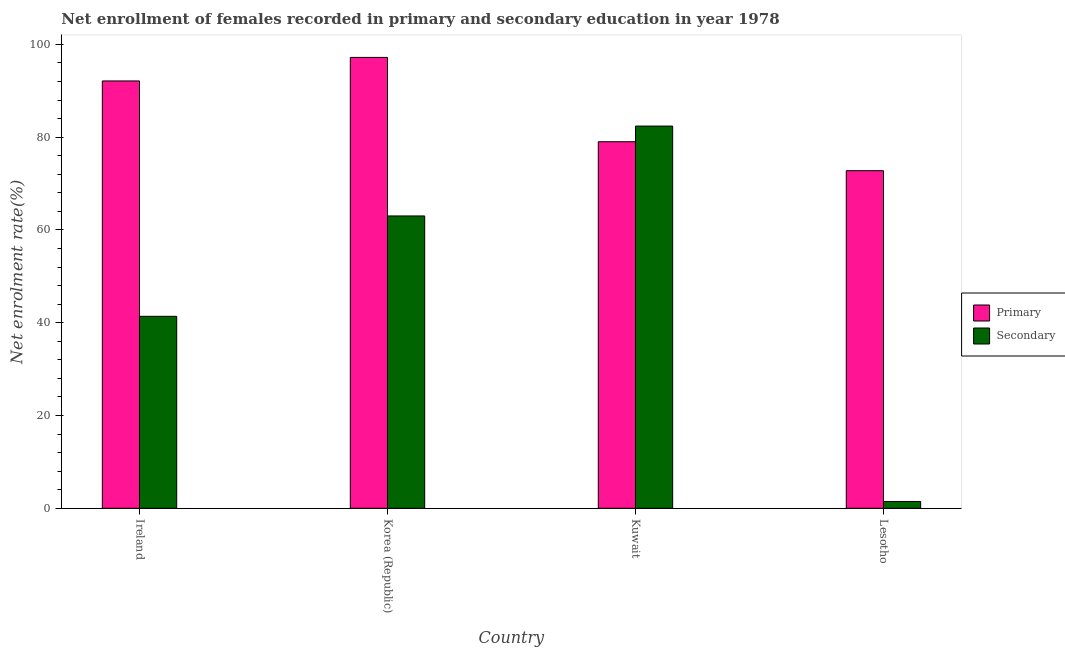How many groups of bars are there?
Offer a terse response. 4. How many bars are there on the 4th tick from the right?
Ensure brevity in your answer.  2. What is the label of the 4th group of bars from the left?
Ensure brevity in your answer.  Lesotho. In how many cases, is the number of bars for a given country not equal to the number of legend labels?
Keep it short and to the point. 0. What is the enrollment rate in primary education in Korea (Republic)?
Your answer should be compact. 97.18. Across all countries, what is the maximum enrollment rate in primary education?
Your answer should be compact. 97.18. Across all countries, what is the minimum enrollment rate in primary education?
Ensure brevity in your answer.  72.76. In which country was the enrollment rate in secondary education minimum?
Offer a very short reply. Lesotho. What is the total enrollment rate in primary education in the graph?
Ensure brevity in your answer.  341.07. What is the difference between the enrollment rate in primary education in Korea (Republic) and that in Kuwait?
Ensure brevity in your answer.  18.17. What is the difference between the enrollment rate in secondary education in Korea (Republic) and the enrollment rate in primary education in Ireland?
Offer a very short reply. -29.1. What is the average enrollment rate in secondary education per country?
Offer a terse response. 47.06. What is the difference between the enrollment rate in secondary education and enrollment rate in primary education in Lesotho?
Give a very brief answer. -71.3. In how many countries, is the enrollment rate in primary education greater than 68 %?
Your response must be concise. 4. What is the ratio of the enrollment rate in primary education in Korea (Republic) to that in Kuwait?
Your answer should be very brief. 1.23. Is the enrollment rate in primary education in Ireland less than that in Korea (Republic)?
Your answer should be compact. Yes. What is the difference between the highest and the second highest enrollment rate in secondary education?
Ensure brevity in your answer.  19.37. What is the difference between the highest and the lowest enrollment rate in primary education?
Keep it short and to the point. 24.42. In how many countries, is the enrollment rate in primary education greater than the average enrollment rate in primary education taken over all countries?
Offer a terse response. 2. What does the 1st bar from the left in Lesotho represents?
Offer a very short reply. Primary. What does the 1st bar from the right in Lesotho represents?
Your answer should be very brief. Secondary. How many countries are there in the graph?
Give a very brief answer. 4. What is the difference between two consecutive major ticks on the Y-axis?
Ensure brevity in your answer.  20. Does the graph contain grids?
Your response must be concise. No. Where does the legend appear in the graph?
Your response must be concise. Center right. How many legend labels are there?
Provide a short and direct response. 2. How are the legend labels stacked?
Keep it short and to the point. Vertical. What is the title of the graph?
Give a very brief answer. Net enrollment of females recorded in primary and secondary education in year 1978. Does "Central government" appear as one of the legend labels in the graph?
Your answer should be very brief. No. What is the label or title of the Y-axis?
Ensure brevity in your answer.  Net enrolment rate(%). What is the Net enrolment rate(%) in Primary in Ireland?
Keep it short and to the point. 92.11. What is the Net enrolment rate(%) in Secondary in Ireland?
Offer a very short reply. 41.38. What is the Net enrolment rate(%) of Primary in Korea (Republic)?
Provide a short and direct response. 97.18. What is the Net enrolment rate(%) of Secondary in Korea (Republic)?
Your answer should be compact. 63.01. What is the Net enrolment rate(%) of Primary in Kuwait?
Your answer should be compact. 79.01. What is the Net enrolment rate(%) in Secondary in Kuwait?
Keep it short and to the point. 82.38. What is the Net enrolment rate(%) in Primary in Lesotho?
Offer a very short reply. 72.76. What is the Net enrolment rate(%) in Secondary in Lesotho?
Keep it short and to the point. 1.47. Across all countries, what is the maximum Net enrolment rate(%) of Primary?
Your answer should be very brief. 97.18. Across all countries, what is the maximum Net enrolment rate(%) of Secondary?
Your answer should be compact. 82.38. Across all countries, what is the minimum Net enrolment rate(%) in Primary?
Provide a succinct answer. 72.76. Across all countries, what is the minimum Net enrolment rate(%) in Secondary?
Provide a succinct answer. 1.47. What is the total Net enrolment rate(%) in Primary in the graph?
Provide a short and direct response. 341.07. What is the total Net enrolment rate(%) of Secondary in the graph?
Ensure brevity in your answer.  188.24. What is the difference between the Net enrolment rate(%) in Primary in Ireland and that in Korea (Republic)?
Provide a succinct answer. -5.07. What is the difference between the Net enrolment rate(%) of Secondary in Ireland and that in Korea (Republic)?
Keep it short and to the point. -21.63. What is the difference between the Net enrolment rate(%) in Primary in Ireland and that in Kuwait?
Give a very brief answer. 13.1. What is the difference between the Net enrolment rate(%) in Secondary in Ireland and that in Kuwait?
Provide a succinct answer. -41.01. What is the difference between the Net enrolment rate(%) of Primary in Ireland and that in Lesotho?
Make the answer very short. 19.34. What is the difference between the Net enrolment rate(%) in Secondary in Ireland and that in Lesotho?
Give a very brief answer. 39.91. What is the difference between the Net enrolment rate(%) in Primary in Korea (Republic) and that in Kuwait?
Provide a short and direct response. 18.17. What is the difference between the Net enrolment rate(%) of Secondary in Korea (Republic) and that in Kuwait?
Offer a terse response. -19.37. What is the difference between the Net enrolment rate(%) of Primary in Korea (Republic) and that in Lesotho?
Provide a short and direct response. 24.42. What is the difference between the Net enrolment rate(%) in Secondary in Korea (Republic) and that in Lesotho?
Provide a short and direct response. 61.54. What is the difference between the Net enrolment rate(%) in Primary in Kuwait and that in Lesotho?
Give a very brief answer. 6.25. What is the difference between the Net enrolment rate(%) in Secondary in Kuwait and that in Lesotho?
Keep it short and to the point. 80.92. What is the difference between the Net enrolment rate(%) of Primary in Ireland and the Net enrolment rate(%) of Secondary in Korea (Republic)?
Your response must be concise. 29.1. What is the difference between the Net enrolment rate(%) in Primary in Ireland and the Net enrolment rate(%) in Secondary in Kuwait?
Your answer should be very brief. 9.73. What is the difference between the Net enrolment rate(%) in Primary in Ireland and the Net enrolment rate(%) in Secondary in Lesotho?
Provide a succinct answer. 90.64. What is the difference between the Net enrolment rate(%) of Primary in Korea (Republic) and the Net enrolment rate(%) of Secondary in Kuwait?
Make the answer very short. 14.8. What is the difference between the Net enrolment rate(%) of Primary in Korea (Republic) and the Net enrolment rate(%) of Secondary in Lesotho?
Your answer should be very brief. 95.72. What is the difference between the Net enrolment rate(%) in Primary in Kuwait and the Net enrolment rate(%) in Secondary in Lesotho?
Make the answer very short. 77.54. What is the average Net enrolment rate(%) of Primary per country?
Offer a very short reply. 85.27. What is the average Net enrolment rate(%) of Secondary per country?
Your answer should be compact. 47.06. What is the difference between the Net enrolment rate(%) in Primary and Net enrolment rate(%) in Secondary in Ireland?
Provide a succinct answer. 50.73. What is the difference between the Net enrolment rate(%) of Primary and Net enrolment rate(%) of Secondary in Korea (Republic)?
Give a very brief answer. 34.17. What is the difference between the Net enrolment rate(%) of Primary and Net enrolment rate(%) of Secondary in Kuwait?
Offer a terse response. -3.37. What is the difference between the Net enrolment rate(%) in Primary and Net enrolment rate(%) in Secondary in Lesotho?
Make the answer very short. 71.3. What is the ratio of the Net enrolment rate(%) in Primary in Ireland to that in Korea (Republic)?
Offer a very short reply. 0.95. What is the ratio of the Net enrolment rate(%) in Secondary in Ireland to that in Korea (Republic)?
Ensure brevity in your answer.  0.66. What is the ratio of the Net enrolment rate(%) of Primary in Ireland to that in Kuwait?
Offer a terse response. 1.17. What is the ratio of the Net enrolment rate(%) of Secondary in Ireland to that in Kuwait?
Keep it short and to the point. 0.5. What is the ratio of the Net enrolment rate(%) in Primary in Ireland to that in Lesotho?
Keep it short and to the point. 1.27. What is the ratio of the Net enrolment rate(%) of Secondary in Ireland to that in Lesotho?
Your answer should be very brief. 28.23. What is the ratio of the Net enrolment rate(%) of Primary in Korea (Republic) to that in Kuwait?
Offer a very short reply. 1.23. What is the ratio of the Net enrolment rate(%) of Secondary in Korea (Republic) to that in Kuwait?
Offer a very short reply. 0.76. What is the ratio of the Net enrolment rate(%) in Primary in Korea (Republic) to that in Lesotho?
Provide a succinct answer. 1.34. What is the ratio of the Net enrolment rate(%) in Secondary in Korea (Republic) to that in Lesotho?
Your answer should be very brief. 42.98. What is the ratio of the Net enrolment rate(%) of Primary in Kuwait to that in Lesotho?
Your response must be concise. 1.09. What is the ratio of the Net enrolment rate(%) in Secondary in Kuwait to that in Lesotho?
Your response must be concise. 56.2. What is the difference between the highest and the second highest Net enrolment rate(%) in Primary?
Offer a terse response. 5.07. What is the difference between the highest and the second highest Net enrolment rate(%) of Secondary?
Provide a short and direct response. 19.37. What is the difference between the highest and the lowest Net enrolment rate(%) in Primary?
Offer a very short reply. 24.42. What is the difference between the highest and the lowest Net enrolment rate(%) in Secondary?
Keep it short and to the point. 80.92. 